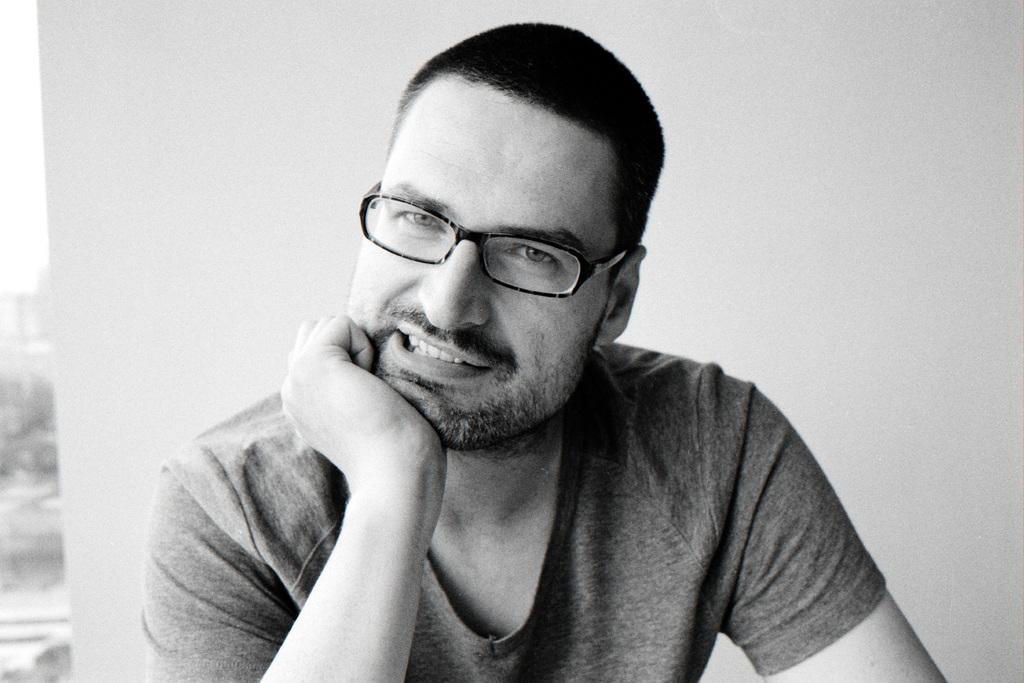Who is the main subject in the picture? There is a man in the middle of the picture. What is the man wearing in the image? The man is wearing spectacles. What can be seen behind the man in the picture? There is a wall visible behind the man. How many badges can be seen on the man's shirt in the image? There are no badges visible on the man's shirt in the image. What type of corn is growing on the wall behind the man? There is no corn present in the image; only the man and the wall are visible. 